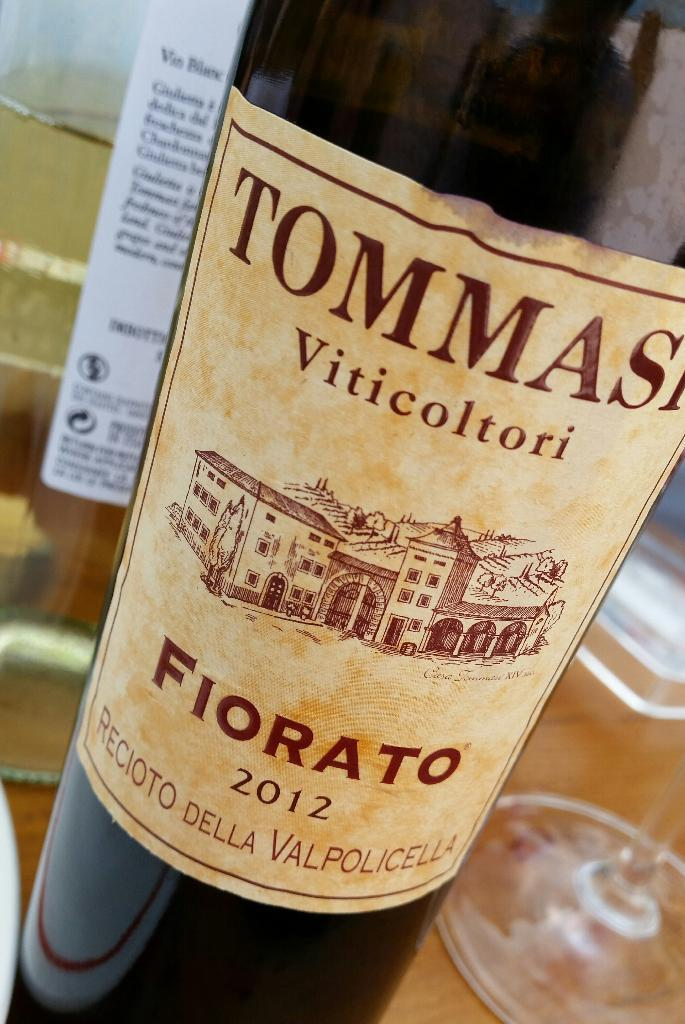Provide a one-sentence caption for the provided image. A bottle of Fiorato sitting on a table near a glass. 